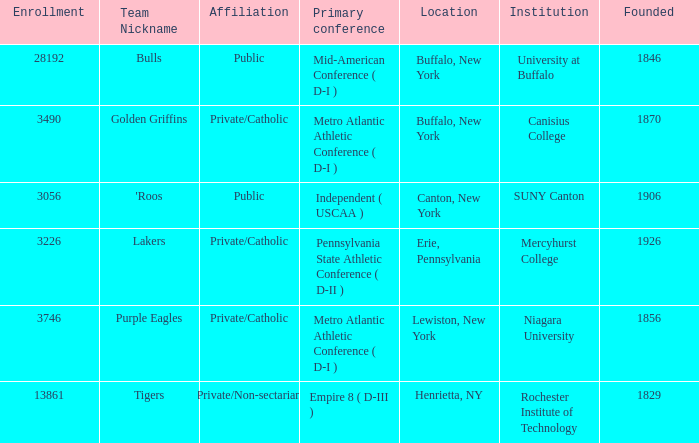What kind of school is Canton, New York? Public. 